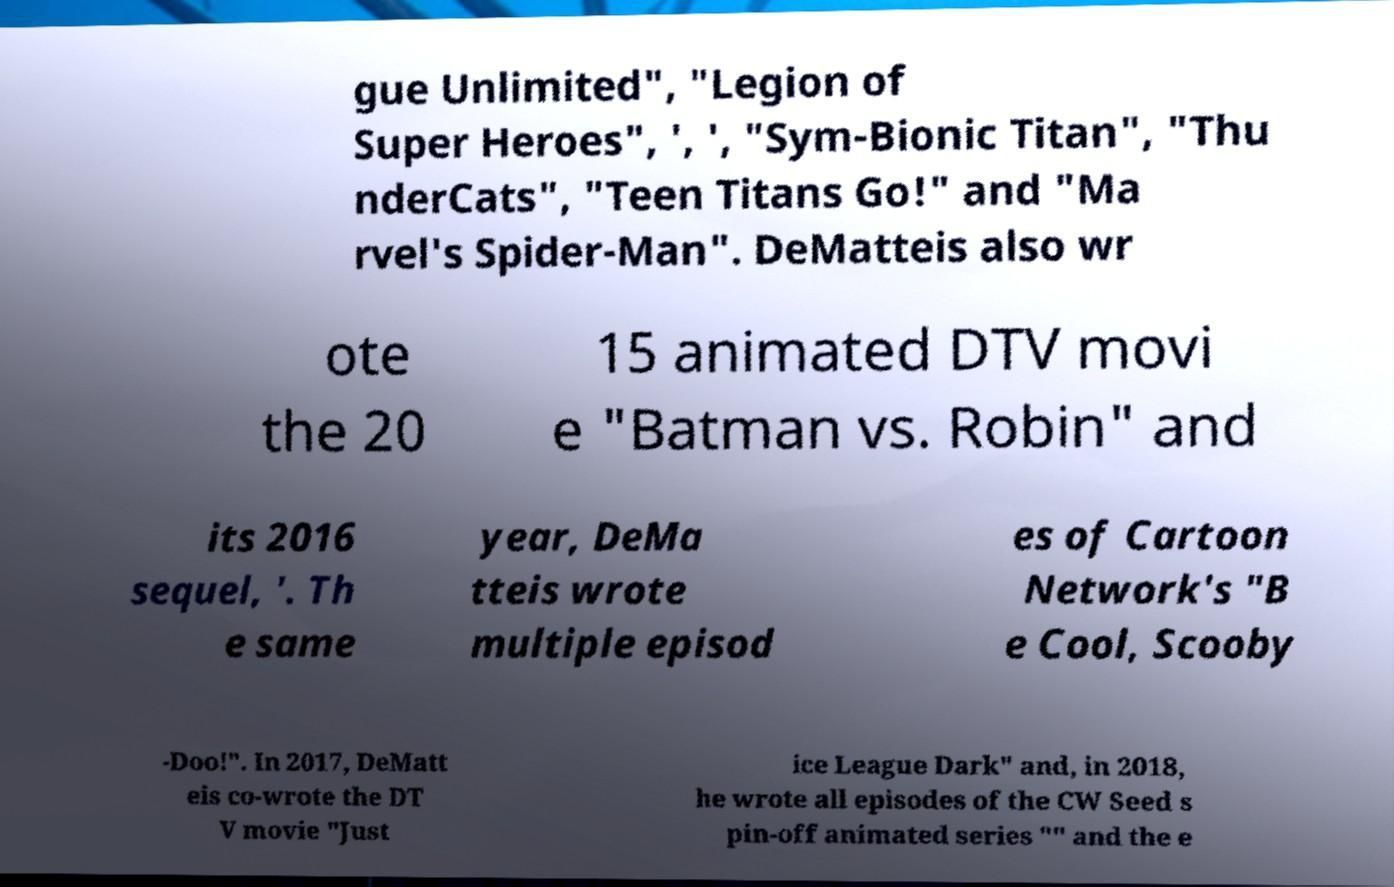There's text embedded in this image that I need extracted. Can you transcribe it verbatim? gue Unlimited", "Legion of Super Heroes", ', ', "Sym-Bionic Titan", "Thu nderCats", "Teen Titans Go!" and "Ma rvel's Spider-Man". DeMatteis also wr ote the 20 15 animated DTV movi e "Batman vs. Robin" and its 2016 sequel, '. Th e same year, DeMa tteis wrote multiple episod es of Cartoon Network's "B e Cool, Scooby -Doo!". In 2017, DeMatt eis co-wrote the DT V movie "Just ice League Dark" and, in 2018, he wrote all episodes of the CW Seed s pin-off animated series "" and the e 